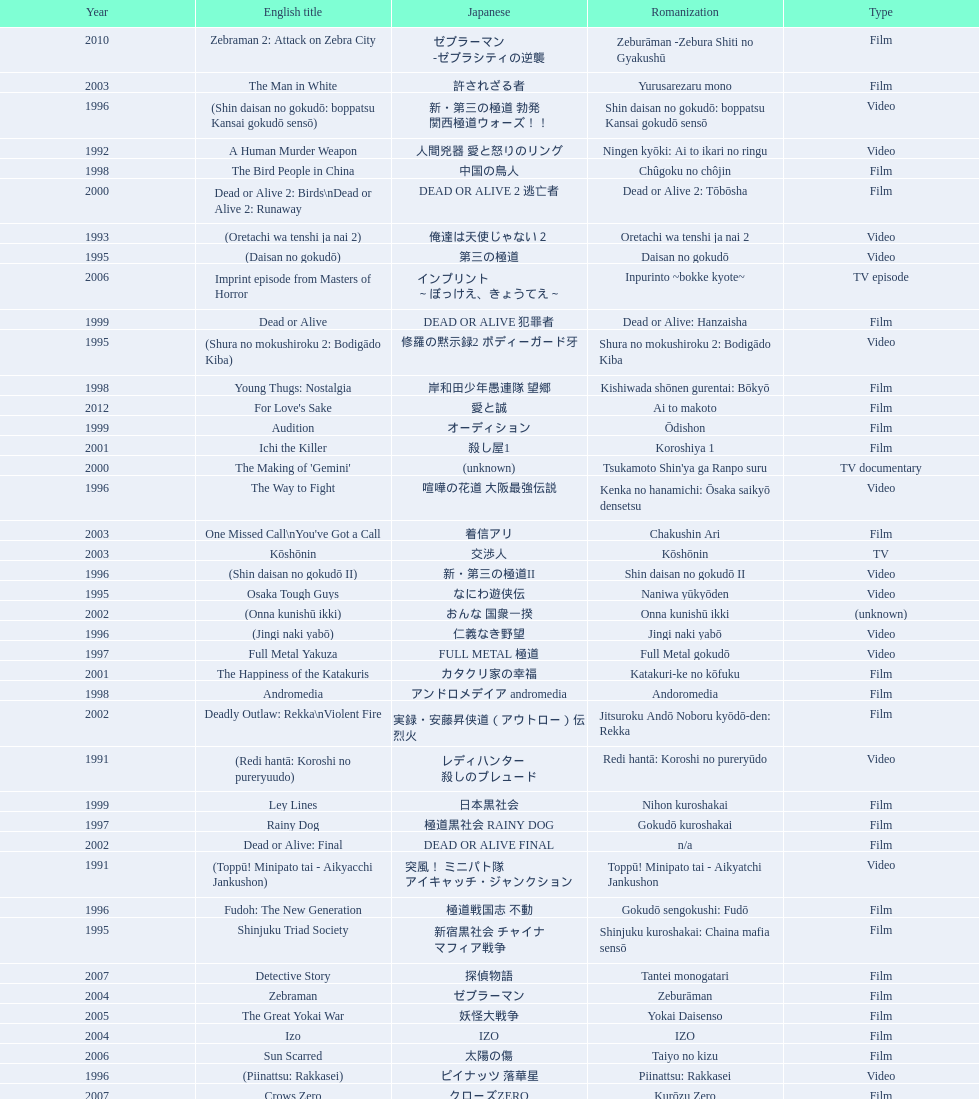Did shinjuku triad society come out as a film or a tv series? Film. 